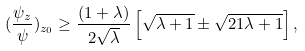<formula> <loc_0><loc_0><loc_500><loc_500>( \frac { \psi _ { z } } { \psi } ) _ { z _ { 0 } } \geq \frac { ( 1 + \lambda ) } { 2 \sqrt { \lambda } } \left [ \sqrt { \lambda + 1 } \pm \sqrt { 2 1 \lambda + 1 } \right ] ,</formula> 